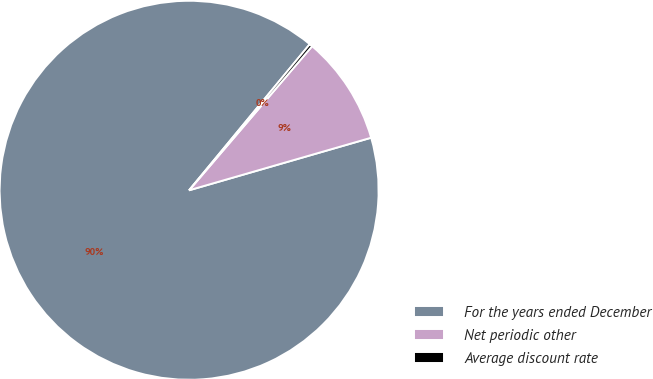<chart> <loc_0><loc_0><loc_500><loc_500><pie_chart><fcel>For the years ended December<fcel>Net periodic other<fcel>Average discount rate<nl><fcel>90.46%<fcel>9.28%<fcel>0.26%<nl></chart> 